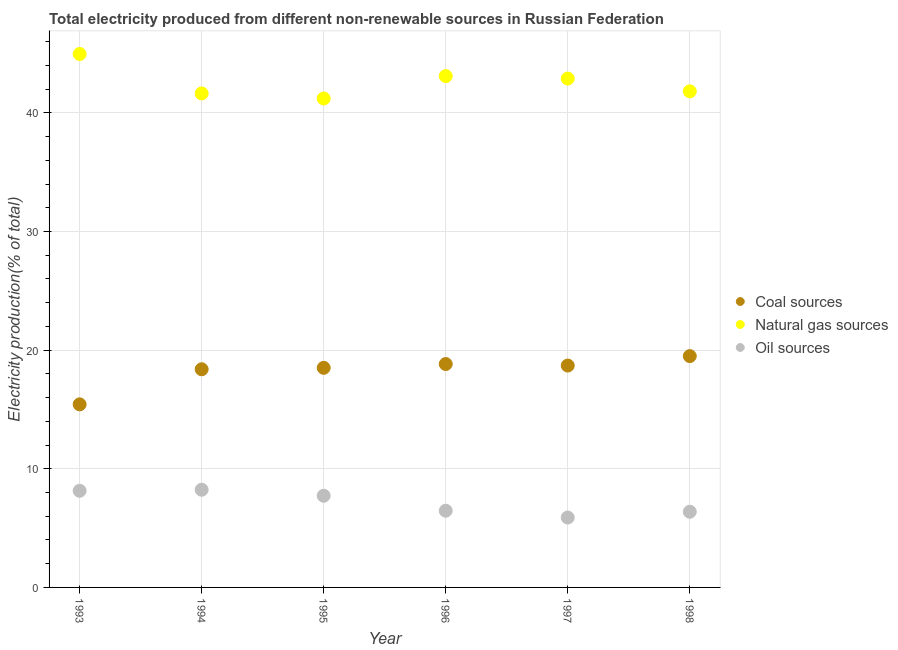How many different coloured dotlines are there?
Your response must be concise. 3. What is the percentage of electricity produced by coal in 1997?
Give a very brief answer. 18.7. Across all years, what is the maximum percentage of electricity produced by coal?
Your response must be concise. 19.5. Across all years, what is the minimum percentage of electricity produced by coal?
Keep it short and to the point. 15.43. In which year was the percentage of electricity produced by oil sources minimum?
Provide a succinct answer. 1997. What is the total percentage of electricity produced by natural gas in the graph?
Your answer should be very brief. 255.64. What is the difference between the percentage of electricity produced by coal in 1994 and that in 1997?
Ensure brevity in your answer.  -0.31. What is the difference between the percentage of electricity produced by oil sources in 1997 and the percentage of electricity produced by natural gas in 1993?
Your response must be concise. -39.07. What is the average percentage of electricity produced by natural gas per year?
Provide a short and direct response. 42.61. In the year 1994, what is the difference between the percentage of electricity produced by coal and percentage of electricity produced by oil sources?
Make the answer very short. 10.16. In how many years, is the percentage of electricity produced by oil sources greater than 12 %?
Give a very brief answer. 0. What is the ratio of the percentage of electricity produced by natural gas in 1994 to that in 1997?
Keep it short and to the point. 0.97. Is the difference between the percentage of electricity produced by natural gas in 1994 and 1995 greater than the difference between the percentage of electricity produced by oil sources in 1994 and 1995?
Ensure brevity in your answer.  No. What is the difference between the highest and the second highest percentage of electricity produced by coal?
Provide a short and direct response. 0.67. What is the difference between the highest and the lowest percentage of electricity produced by oil sources?
Provide a short and direct response. 2.34. Is the sum of the percentage of electricity produced by natural gas in 1993 and 1997 greater than the maximum percentage of electricity produced by oil sources across all years?
Your answer should be compact. Yes. Is it the case that in every year, the sum of the percentage of electricity produced by coal and percentage of electricity produced by natural gas is greater than the percentage of electricity produced by oil sources?
Your response must be concise. Yes. Does the percentage of electricity produced by coal monotonically increase over the years?
Provide a short and direct response. No. Is the percentage of electricity produced by natural gas strictly less than the percentage of electricity produced by oil sources over the years?
Give a very brief answer. No. How many dotlines are there?
Keep it short and to the point. 3. Does the graph contain grids?
Provide a short and direct response. Yes. How are the legend labels stacked?
Your answer should be very brief. Vertical. What is the title of the graph?
Your answer should be very brief. Total electricity produced from different non-renewable sources in Russian Federation. What is the Electricity production(% of total) in Coal sources in 1993?
Give a very brief answer. 15.43. What is the Electricity production(% of total) of Natural gas sources in 1993?
Offer a terse response. 44.97. What is the Electricity production(% of total) in Oil sources in 1993?
Ensure brevity in your answer.  8.15. What is the Electricity production(% of total) in Coal sources in 1994?
Your answer should be compact. 18.39. What is the Electricity production(% of total) in Natural gas sources in 1994?
Provide a short and direct response. 41.64. What is the Electricity production(% of total) of Oil sources in 1994?
Keep it short and to the point. 8.23. What is the Electricity production(% of total) of Coal sources in 1995?
Your answer should be compact. 18.51. What is the Electricity production(% of total) of Natural gas sources in 1995?
Make the answer very short. 41.22. What is the Electricity production(% of total) in Oil sources in 1995?
Provide a succinct answer. 7.73. What is the Electricity production(% of total) in Coal sources in 1996?
Keep it short and to the point. 18.83. What is the Electricity production(% of total) of Natural gas sources in 1996?
Offer a terse response. 43.1. What is the Electricity production(% of total) of Oil sources in 1996?
Provide a succinct answer. 6.47. What is the Electricity production(% of total) in Coal sources in 1997?
Your answer should be compact. 18.7. What is the Electricity production(% of total) of Natural gas sources in 1997?
Ensure brevity in your answer.  42.9. What is the Electricity production(% of total) in Oil sources in 1997?
Keep it short and to the point. 5.89. What is the Electricity production(% of total) of Coal sources in 1998?
Your response must be concise. 19.5. What is the Electricity production(% of total) of Natural gas sources in 1998?
Your answer should be very brief. 41.82. What is the Electricity production(% of total) in Oil sources in 1998?
Give a very brief answer. 6.38. Across all years, what is the maximum Electricity production(% of total) of Coal sources?
Provide a short and direct response. 19.5. Across all years, what is the maximum Electricity production(% of total) in Natural gas sources?
Make the answer very short. 44.97. Across all years, what is the maximum Electricity production(% of total) in Oil sources?
Keep it short and to the point. 8.23. Across all years, what is the minimum Electricity production(% of total) of Coal sources?
Provide a succinct answer. 15.43. Across all years, what is the minimum Electricity production(% of total) in Natural gas sources?
Offer a terse response. 41.22. Across all years, what is the minimum Electricity production(% of total) in Oil sources?
Give a very brief answer. 5.89. What is the total Electricity production(% of total) of Coal sources in the graph?
Provide a succinct answer. 109.37. What is the total Electricity production(% of total) of Natural gas sources in the graph?
Your response must be concise. 255.64. What is the total Electricity production(% of total) of Oil sources in the graph?
Ensure brevity in your answer.  42.85. What is the difference between the Electricity production(% of total) of Coal sources in 1993 and that in 1994?
Offer a terse response. -2.96. What is the difference between the Electricity production(% of total) in Natural gas sources in 1993 and that in 1994?
Offer a very short reply. 3.32. What is the difference between the Electricity production(% of total) in Oil sources in 1993 and that in 1994?
Keep it short and to the point. -0.09. What is the difference between the Electricity production(% of total) of Coal sources in 1993 and that in 1995?
Ensure brevity in your answer.  -3.08. What is the difference between the Electricity production(% of total) in Natural gas sources in 1993 and that in 1995?
Your answer should be very brief. 3.75. What is the difference between the Electricity production(% of total) of Oil sources in 1993 and that in 1995?
Keep it short and to the point. 0.42. What is the difference between the Electricity production(% of total) in Coal sources in 1993 and that in 1996?
Your response must be concise. -3.4. What is the difference between the Electricity production(% of total) of Natural gas sources in 1993 and that in 1996?
Your answer should be compact. 1.86. What is the difference between the Electricity production(% of total) in Oil sources in 1993 and that in 1996?
Provide a succinct answer. 1.68. What is the difference between the Electricity production(% of total) in Coal sources in 1993 and that in 1997?
Keep it short and to the point. -3.27. What is the difference between the Electricity production(% of total) in Natural gas sources in 1993 and that in 1997?
Provide a succinct answer. 2.07. What is the difference between the Electricity production(% of total) in Oil sources in 1993 and that in 1997?
Provide a short and direct response. 2.26. What is the difference between the Electricity production(% of total) in Coal sources in 1993 and that in 1998?
Give a very brief answer. -4.07. What is the difference between the Electricity production(% of total) in Natural gas sources in 1993 and that in 1998?
Offer a very short reply. 3.15. What is the difference between the Electricity production(% of total) in Oil sources in 1993 and that in 1998?
Ensure brevity in your answer.  1.77. What is the difference between the Electricity production(% of total) in Coal sources in 1994 and that in 1995?
Offer a terse response. -0.12. What is the difference between the Electricity production(% of total) of Natural gas sources in 1994 and that in 1995?
Make the answer very short. 0.43. What is the difference between the Electricity production(% of total) of Oil sources in 1994 and that in 1995?
Give a very brief answer. 0.51. What is the difference between the Electricity production(% of total) of Coal sources in 1994 and that in 1996?
Offer a terse response. -0.44. What is the difference between the Electricity production(% of total) of Natural gas sources in 1994 and that in 1996?
Provide a short and direct response. -1.46. What is the difference between the Electricity production(% of total) of Oil sources in 1994 and that in 1996?
Your response must be concise. 1.77. What is the difference between the Electricity production(% of total) in Coal sources in 1994 and that in 1997?
Provide a succinct answer. -0.31. What is the difference between the Electricity production(% of total) of Natural gas sources in 1994 and that in 1997?
Your response must be concise. -1.25. What is the difference between the Electricity production(% of total) in Oil sources in 1994 and that in 1997?
Your answer should be very brief. 2.34. What is the difference between the Electricity production(% of total) of Coal sources in 1994 and that in 1998?
Provide a succinct answer. -1.11. What is the difference between the Electricity production(% of total) of Natural gas sources in 1994 and that in 1998?
Ensure brevity in your answer.  -0.18. What is the difference between the Electricity production(% of total) of Oil sources in 1994 and that in 1998?
Provide a succinct answer. 1.86. What is the difference between the Electricity production(% of total) in Coal sources in 1995 and that in 1996?
Provide a short and direct response. -0.32. What is the difference between the Electricity production(% of total) of Natural gas sources in 1995 and that in 1996?
Give a very brief answer. -1.89. What is the difference between the Electricity production(% of total) in Oil sources in 1995 and that in 1996?
Keep it short and to the point. 1.26. What is the difference between the Electricity production(% of total) in Coal sources in 1995 and that in 1997?
Your answer should be very brief. -0.19. What is the difference between the Electricity production(% of total) of Natural gas sources in 1995 and that in 1997?
Offer a terse response. -1.68. What is the difference between the Electricity production(% of total) of Oil sources in 1995 and that in 1997?
Offer a terse response. 1.84. What is the difference between the Electricity production(% of total) of Coal sources in 1995 and that in 1998?
Your answer should be compact. -0.99. What is the difference between the Electricity production(% of total) in Natural gas sources in 1995 and that in 1998?
Your answer should be compact. -0.6. What is the difference between the Electricity production(% of total) in Oil sources in 1995 and that in 1998?
Keep it short and to the point. 1.35. What is the difference between the Electricity production(% of total) of Coal sources in 1996 and that in 1997?
Ensure brevity in your answer.  0.13. What is the difference between the Electricity production(% of total) of Natural gas sources in 1996 and that in 1997?
Ensure brevity in your answer.  0.21. What is the difference between the Electricity production(% of total) of Oil sources in 1996 and that in 1997?
Provide a short and direct response. 0.57. What is the difference between the Electricity production(% of total) of Coal sources in 1996 and that in 1998?
Your response must be concise. -0.67. What is the difference between the Electricity production(% of total) of Natural gas sources in 1996 and that in 1998?
Offer a very short reply. 1.28. What is the difference between the Electricity production(% of total) of Oil sources in 1996 and that in 1998?
Your response must be concise. 0.09. What is the difference between the Electricity production(% of total) of Coal sources in 1997 and that in 1998?
Ensure brevity in your answer.  -0.79. What is the difference between the Electricity production(% of total) in Natural gas sources in 1997 and that in 1998?
Provide a short and direct response. 1.08. What is the difference between the Electricity production(% of total) in Oil sources in 1997 and that in 1998?
Your answer should be compact. -0.49. What is the difference between the Electricity production(% of total) of Coal sources in 1993 and the Electricity production(% of total) of Natural gas sources in 1994?
Ensure brevity in your answer.  -26.21. What is the difference between the Electricity production(% of total) in Coal sources in 1993 and the Electricity production(% of total) in Oil sources in 1994?
Make the answer very short. 7.2. What is the difference between the Electricity production(% of total) of Natural gas sources in 1993 and the Electricity production(% of total) of Oil sources in 1994?
Offer a terse response. 36.73. What is the difference between the Electricity production(% of total) of Coal sources in 1993 and the Electricity production(% of total) of Natural gas sources in 1995?
Your response must be concise. -25.78. What is the difference between the Electricity production(% of total) in Coal sources in 1993 and the Electricity production(% of total) in Oil sources in 1995?
Your answer should be compact. 7.7. What is the difference between the Electricity production(% of total) of Natural gas sources in 1993 and the Electricity production(% of total) of Oil sources in 1995?
Your answer should be compact. 37.24. What is the difference between the Electricity production(% of total) in Coal sources in 1993 and the Electricity production(% of total) in Natural gas sources in 1996?
Your answer should be compact. -27.67. What is the difference between the Electricity production(% of total) in Coal sources in 1993 and the Electricity production(% of total) in Oil sources in 1996?
Keep it short and to the point. 8.97. What is the difference between the Electricity production(% of total) in Natural gas sources in 1993 and the Electricity production(% of total) in Oil sources in 1996?
Give a very brief answer. 38.5. What is the difference between the Electricity production(% of total) in Coal sources in 1993 and the Electricity production(% of total) in Natural gas sources in 1997?
Keep it short and to the point. -27.46. What is the difference between the Electricity production(% of total) of Coal sources in 1993 and the Electricity production(% of total) of Oil sources in 1997?
Give a very brief answer. 9.54. What is the difference between the Electricity production(% of total) of Natural gas sources in 1993 and the Electricity production(% of total) of Oil sources in 1997?
Your answer should be very brief. 39.07. What is the difference between the Electricity production(% of total) of Coal sources in 1993 and the Electricity production(% of total) of Natural gas sources in 1998?
Provide a short and direct response. -26.39. What is the difference between the Electricity production(% of total) of Coal sources in 1993 and the Electricity production(% of total) of Oil sources in 1998?
Offer a terse response. 9.05. What is the difference between the Electricity production(% of total) of Natural gas sources in 1993 and the Electricity production(% of total) of Oil sources in 1998?
Your answer should be very brief. 38.59. What is the difference between the Electricity production(% of total) of Coal sources in 1994 and the Electricity production(% of total) of Natural gas sources in 1995?
Your answer should be very brief. -22.82. What is the difference between the Electricity production(% of total) of Coal sources in 1994 and the Electricity production(% of total) of Oil sources in 1995?
Make the answer very short. 10.66. What is the difference between the Electricity production(% of total) of Natural gas sources in 1994 and the Electricity production(% of total) of Oil sources in 1995?
Ensure brevity in your answer.  33.91. What is the difference between the Electricity production(% of total) in Coal sources in 1994 and the Electricity production(% of total) in Natural gas sources in 1996?
Your answer should be compact. -24.71. What is the difference between the Electricity production(% of total) of Coal sources in 1994 and the Electricity production(% of total) of Oil sources in 1996?
Your response must be concise. 11.93. What is the difference between the Electricity production(% of total) of Natural gas sources in 1994 and the Electricity production(% of total) of Oil sources in 1996?
Make the answer very short. 35.18. What is the difference between the Electricity production(% of total) of Coal sources in 1994 and the Electricity production(% of total) of Natural gas sources in 1997?
Make the answer very short. -24.51. What is the difference between the Electricity production(% of total) in Coal sources in 1994 and the Electricity production(% of total) in Oil sources in 1997?
Keep it short and to the point. 12.5. What is the difference between the Electricity production(% of total) in Natural gas sources in 1994 and the Electricity production(% of total) in Oil sources in 1997?
Keep it short and to the point. 35.75. What is the difference between the Electricity production(% of total) in Coal sources in 1994 and the Electricity production(% of total) in Natural gas sources in 1998?
Your answer should be very brief. -23.43. What is the difference between the Electricity production(% of total) of Coal sources in 1994 and the Electricity production(% of total) of Oil sources in 1998?
Your response must be concise. 12.01. What is the difference between the Electricity production(% of total) in Natural gas sources in 1994 and the Electricity production(% of total) in Oil sources in 1998?
Keep it short and to the point. 35.26. What is the difference between the Electricity production(% of total) of Coal sources in 1995 and the Electricity production(% of total) of Natural gas sources in 1996?
Provide a short and direct response. -24.59. What is the difference between the Electricity production(% of total) of Coal sources in 1995 and the Electricity production(% of total) of Oil sources in 1996?
Offer a terse response. 12.05. What is the difference between the Electricity production(% of total) in Natural gas sources in 1995 and the Electricity production(% of total) in Oil sources in 1996?
Keep it short and to the point. 34.75. What is the difference between the Electricity production(% of total) of Coal sources in 1995 and the Electricity production(% of total) of Natural gas sources in 1997?
Your answer should be compact. -24.38. What is the difference between the Electricity production(% of total) of Coal sources in 1995 and the Electricity production(% of total) of Oil sources in 1997?
Your response must be concise. 12.62. What is the difference between the Electricity production(% of total) of Natural gas sources in 1995 and the Electricity production(% of total) of Oil sources in 1997?
Your answer should be very brief. 35.32. What is the difference between the Electricity production(% of total) in Coal sources in 1995 and the Electricity production(% of total) in Natural gas sources in 1998?
Offer a terse response. -23.31. What is the difference between the Electricity production(% of total) in Coal sources in 1995 and the Electricity production(% of total) in Oil sources in 1998?
Keep it short and to the point. 12.13. What is the difference between the Electricity production(% of total) of Natural gas sources in 1995 and the Electricity production(% of total) of Oil sources in 1998?
Offer a very short reply. 34.84. What is the difference between the Electricity production(% of total) of Coal sources in 1996 and the Electricity production(% of total) of Natural gas sources in 1997?
Offer a terse response. -24.07. What is the difference between the Electricity production(% of total) of Coal sources in 1996 and the Electricity production(% of total) of Oil sources in 1997?
Make the answer very short. 12.94. What is the difference between the Electricity production(% of total) in Natural gas sources in 1996 and the Electricity production(% of total) in Oil sources in 1997?
Offer a very short reply. 37.21. What is the difference between the Electricity production(% of total) in Coal sources in 1996 and the Electricity production(% of total) in Natural gas sources in 1998?
Offer a very short reply. -22.99. What is the difference between the Electricity production(% of total) in Coal sources in 1996 and the Electricity production(% of total) in Oil sources in 1998?
Offer a very short reply. 12.45. What is the difference between the Electricity production(% of total) in Natural gas sources in 1996 and the Electricity production(% of total) in Oil sources in 1998?
Make the answer very short. 36.72. What is the difference between the Electricity production(% of total) in Coal sources in 1997 and the Electricity production(% of total) in Natural gas sources in 1998?
Your response must be concise. -23.12. What is the difference between the Electricity production(% of total) in Coal sources in 1997 and the Electricity production(% of total) in Oil sources in 1998?
Your answer should be compact. 12.33. What is the difference between the Electricity production(% of total) in Natural gas sources in 1997 and the Electricity production(% of total) in Oil sources in 1998?
Your answer should be very brief. 36.52. What is the average Electricity production(% of total) in Coal sources per year?
Provide a short and direct response. 18.23. What is the average Electricity production(% of total) in Natural gas sources per year?
Your answer should be compact. 42.61. What is the average Electricity production(% of total) of Oil sources per year?
Your response must be concise. 7.14. In the year 1993, what is the difference between the Electricity production(% of total) of Coal sources and Electricity production(% of total) of Natural gas sources?
Offer a terse response. -29.53. In the year 1993, what is the difference between the Electricity production(% of total) of Coal sources and Electricity production(% of total) of Oil sources?
Ensure brevity in your answer.  7.29. In the year 1993, what is the difference between the Electricity production(% of total) of Natural gas sources and Electricity production(% of total) of Oil sources?
Offer a very short reply. 36.82. In the year 1994, what is the difference between the Electricity production(% of total) of Coal sources and Electricity production(% of total) of Natural gas sources?
Offer a very short reply. -23.25. In the year 1994, what is the difference between the Electricity production(% of total) in Coal sources and Electricity production(% of total) in Oil sources?
Your answer should be very brief. 10.16. In the year 1994, what is the difference between the Electricity production(% of total) in Natural gas sources and Electricity production(% of total) in Oil sources?
Offer a very short reply. 33.41. In the year 1995, what is the difference between the Electricity production(% of total) in Coal sources and Electricity production(% of total) in Natural gas sources?
Give a very brief answer. -22.7. In the year 1995, what is the difference between the Electricity production(% of total) of Coal sources and Electricity production(% of total) of Oil sources?
Provide a short and direct response. 10.78. In the year 1995, what is the difference between the Electricity production(% of total) in Natural gas sources and Electricity production(% of total) in Oil sources?
Keep it short and to the point. 33.49. In the year 1996, what is the difference between the Electricity production(% of total) of Coal sources and Electricity production(% of total) of Natural gas sources?
Ensure brevity in your answer.  -24.27. In the year 1996, what is the difference between the Electricity production(% of total) of Coal sources and Electricity production(% of total) of Oil sources?
Offer a very short reply. 12.37. In the year 1996, what is the difference between the Electricity production(% of total) of Natural gas sources and Electricity production(% of total) of Oil sources?
Give a very brief answer. 36.64. In the year 1997, what is the difference between the Electricity production(% of total) in Coal sources and Electricity production(% of total) in Natural gas sources?
Make the answer very short. -24.19. In the year 1997, what is the difference between the Electricity production(% of total) of Coal sources and Electricity production(% of total) of Oil sources?
Make the answer very short. 12.81. In the year 1997, what is the difference between the Electricity production(% of total) in Natural gas sources and Electricity production(% of total) in Oil sources?
Your response must be concise. 37. In the year 1998, what is the difference between the Electricity production(% of total) of Coal sources and Electricity production(% of total) of Natural gas sources?
Provide a succinct answer. -22.32. In the year 1998, what is the difference between the Electricity production(% of total) in Coal sources and Electricity production(% of total) in Oil sources?
Keep it short and to the point. 13.12. In the year 1998, what is the difference between the Electricity production(% of total) in Natural gas sources and Electricity production(% of total) in Oil sources?
Offer a terse response. 35.44. What is the ratio of the Electricity production(% of total) in Coal sources in 1993 to that in 1994?
Offer a terse response. 0.84. What is the ratio of the Electricity production(% of total) of Natural gas sources in 1993 to that in 1994?
Offer a very short reply. 1.08. What is the ratio of the Electricity production(% of total) of Oil sources in 1993 to that in 1994?
Keep it short and to the point. 0.99. What is the ratio of the Electricity production(% of total) in Coal sources in 1993 to that in 1995?
Give a very brief answer. 0.83. What is the ratio of the Electricity production(% of total) of Natural gas sources in 1993 to that in 1995?
Keep it short and to the point. 1.09. What is the ratio of the Electricity production(% of total) of Oil sources in 1993 to that in 1995?
Make the answer very short. 1.05. What is the ratio of the Electricity production(% of total) in Coal sources in 1993 to that in 1996?
Offer a very short reply. 0.82. What is the ratio of the Electricity production(% of total) of Natural gas sources in 1993 to that in 1996?
Offer a terse response. 1.04. What is the ratio of the Electricity production(% of total) in Oil sources in 1993 to that in 1996?
Give a very brief answer. 1.26. What is the ratio of the Electricity production(% of total) of Coal sources in 1993 to that in 1997?
Your response must be concise. 0.83. What is the ratio of the Electricity production(% of total) of Natural gas sources in 1993 to that in 1997?
Offer a terse response. 1.05. What is the ratio of the Electricity production(% of total) in Oil sources in 1993 to that in 1997?
Your answer should be very brief. 1.38. What is the ratio of the Electricity production(% of total) of Coal sources in 1993 to that in 1998?
Your answer should be very brief. 0.79. What is the ratio of the Electricity production(% of total) of Natural gas sources in 1993 to that in 1998?
Your answer should be very brief. 1.08. What is the ratio of the Electricity production(% of total) of Oil sources in 1993 to that in 1998?
Offer a very short reply. 1.28. What is the ratio of the Electricity production(% of total) of Natural gas sources in 1994 to that in 1995?
Provide a succinct answer. 1.01. What is the ratio of the Electricity production(% of total) in Oil sources in 1994 to that in 1995?
Your answer should be compact. 1.07. What is the ratio of the Electricity production(% of total) of Coal sources in 1994 to that in 1996?
Your answer should be very brief. 0.98. What is the ratio of the Electricity production(% of total) in Natural gas sources in 1994 to that in 1996?
Your response must be concise. 0.97. What is the ratio of the Electricity production(% of total) in Oil sources in 1994 to that in 1996?
Your answer should be compact. 1.27. What is the ratio of the Electricity production(% of total) of Coal sources in 1994 to that in 1997?
Your response must be concise. 0.98. What is the ratio of the Electricity production(% of total) of Natural gas sources in 1994 to that in 1997?
Provide a succinct answer. 0.97. What is the ratio of the Electricity production(% of total) of Oil sources in 1994 to that in 1997?
Keep it short and to the point. 1.4. What is the ratio of the Electricity production(% of total) in Coal sources in 1994 to that in 1998?
Make the answer very short. 0.94. What is the ratio of the Electricity production(% of total) of Oil sources in 1994 to that in 1998?
Provide a succinct answer. 1.29. What is the ratio of the Electricity production(% of total) in Coal sources in 1995 to that in 1996?
Give a very brief answer. 0.98. What is the ratio of the Electricity production(% of total) of Natural gas sources in 1995 to that in 1996?
Make the answer very short. 0.96. What is the ratio of the Electricity production(% of total) of Oil sources in 1995 to that in 1996?
Make the answer very short. 1.2. What is the ratio of the Electricity production(% of total) of Coal sources in 1995 to that in 1997?
Offer a terse response. 0.99. What is the ratio of the Electricity production(% of total) in Natural gas sources in 1995 to that in 1997?
Make the answer very short. 0.96. What is the ratio of the Electricity production(% of total) in Oil sources in 1995 to that in 1997?
Offer a very short reply. 1.31. What is the ratio of the Electricity production(% of total) of Coal sources in 1995 to that in 1998?
Offer a very short reply. 0.95. What is the ratio of the Electricity production(% of total) in Natural gas sources in 1995 to that in 1998?
Offer a terse response. 0.99. What is the ratio of the Electricity production(% of total) in Oil sources in 1995 to that in 1998?
Keep it short and to the point. 1.21. What is the ratio of the Electricity production(% of total) in Coal sources in 1996 to that in 1997?
Offer a very short reply. 1.01. What is the ratio of the Electricity production(% of total) of Oil sources in 1996 to that in 1997?
Make the answer very short. 1.1. What is the ratio of the Electricity production(% of total) in Coal sources in 1996 to that in 1998?
Your answer should be very brief. 0.97. What is the ratio of the Electricity production(% of total) of Natural gas sources in 1996 to that in 1998?
Your answer should be very brief. 1.03. What is the ratio of the Electricity production(% of total) in Oil sources in 1996 to that in 1998?
Provide a succinct answer. 1.01. What is the ratio of the Electricity production(% of total) of Coal sources in 1997 to that in 1998?
Provide a succinct answer. 0.96. What is the ratio of the Electricity production(% of total) in Natural gas sources in 1997 to that in 1998?
Ensure brevity in your answer.  1.03. What is the ratio of the Electricity production(% of total) in Oil sources in 1997 to that in 1998?
Provide a succinct answer. 0.92. What is the difference between the highest and the second highest Electricity production(% of total) in Coal sources?
Give a very brief answer. 0.67. What is the difference between the highest and the second highest Electricity production(% of total) of Natural gas sources?
Your answer should be compact. 1.86. What is the difference between the highest and the second highest Electricity production(% of total) in Oil sources?
Offer a terse response. 0.09. What is the difference between the highest and the lowest Electricity production(% of total) in Coal sources?
Offer a terse response. 4.07. What is the difference between the highest and the lowest Electricity production(% of total) in Natural gas sources?
Make the answer very short. 3.75. What is the difference between the highest and the lowest Electricity production(% of total) of Oil sources?
Make the answer very short. 2.34. 